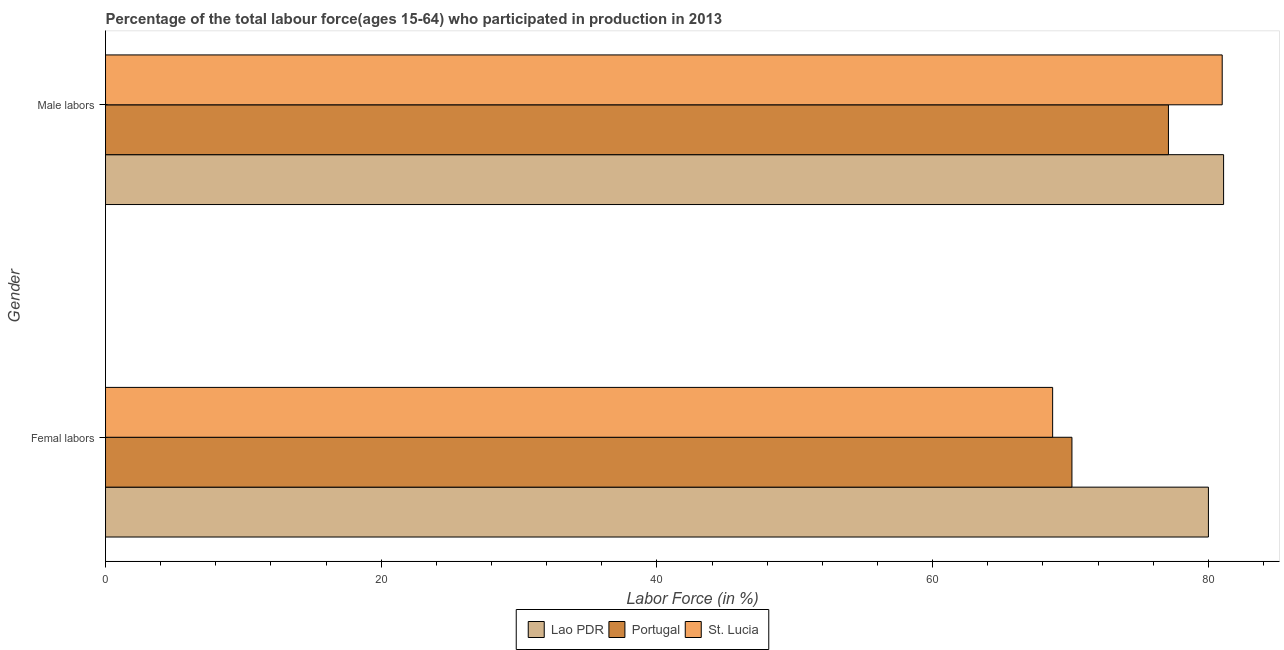How many different coloured bars are there?
Provide a short and direct response. 3. Are the number of bars per tick equal to the number of legend labels?
Your answer should be very brief. Yes. How many bars are there on the 1st tick from the top?
Your answer should be compact. 3. What is the label of the 2nd group of bars from the top?
Provide a short and direct response. Femal labors. What is the percentage of female labor force in Portugal?
Give a very brief answer. 70.1. Across all countries, what is the maximum percentage of female labor force?
Make the answer very short. 80. Across all countries, what is the minimum percentage of female labor force?
Your answer should be compact. 68.7. In which country was the percentage of male labour force maximum?
Keep it short and to the point. Lao PDR. In which country was the percentage of female labor force minimum?
Make the answer very short. St. Lucia. What is the total percentage of female labor force in the graph?
Provide a succinct answer. 218.8. What is the difference between the percentage of female labor force in St. Lucia and that in Portugal?
Your response must be concise. -1.4. What is the difference between the percentage of female labor force in Lao PDR and the percentage of male labour force in St. Lucia?
Provide a short and direct response. -1. What is the average percentage of male labour force per country?
Provide a succinct answer. 79.73. What is the difference between the percentage of male labour force and percentage of female labor force in Portugal?
Make the answer very short. 7. In how many countries, is the percentage of male labour force greater than 8 %?
Make the answer very short. 3. What is the ratio of the percentage of male labour force in Portugal to that in Lao PDR?
Keep it short and to the point. 0.95. Is the percentage of female labor force in Lao PDR less than that in St. Lucia?
Give a very brief answer. No. In how many countries, is the percentage of male labour force greater than the average percentage of male labour force taken over all countries?
Give a very brief answer. 2. What does the 1st bar from the top in Femal labors represents?
Provide a succinct answer. St. Lucia. What does the 1st bar from the bottom in Femal labors represents?
Offer a very short reply. Lao PDR. How many bars are there?
Provide a short and direct response. 6. How many countries are there in the graph?
Your answer should be compact. 3. What is the difference between two consecutive major ticks on the X-axis?
Your answer should be compact. 20. Does the graph contain any zero values?
Provide a succinct answer. No. Does the graph contain grids?
Offer a very short reply. No. How are the legend labels stacked?
Provide a short and direct response. Horizontal. What is the title of the graph?
Give a very brief answer. Percentage of the total labour force(ages 15-64) who participated in production in 2013. What is the label or title of the Y-axis?
Provide a short and direct response. Gender. What is the Labor Force (in %) in Portugal in Femal labors?
Offer a very short reply. 70.1. What is the Labor Force (in %) in St. Lucia in Femal labors?
Provide a short and direct response. 68.7. What is the Labor Force (in %) of Lao PDR in Male labors?
Your answer should be very brief. 81.1. What is the Labor Force (in %) of Portugal in Male labors?
Offer a very short reply. 77.1. What is the Labor Force (in %) in St. Lucia in Male labors?
Keep it short and to the point. 81. Across all Gender, what is the maximum Labor Force (in %) in Lao PDR?
Offer a terse response. 81.1. Across all Gender, what is the maximum Labor Force (in %) in Portugal?
Provide a succinct answer. 77.1. Across all Gender, what is the maximum Labor Force (in %) in St. Lucia?
Give a very brief answer. 81. Across all Gender, what is the minimum Labor Force (in %) of Lao PDR?
Provide a succinct answer. 80. Across all Gender, what is the minimum Labor Force (in %) in Portugal?
Ensure brevity in your answer.  70.1. Across all Gender, what is the minimum Labor Force (in %) in St. Lucia?
Make the answer very short. 68.7. What is the total Labor Force (in %) in Lao PDR in the graph?
Ensure brevity in your answer.  161.1. What is the total Labor Force (in %) in Portugal in the graph?
Your response must be concise. 147.2. What is the total Labor Force (in %) in St. Lucia in the graph?
Provide a succinct answer. 149.7. What is the difference between the Labor Force (in %) in Portugal in Femal labors and that in Male labors?
Your answer should be compact. -7. What is the difference between the Labor Force (in %) of Lao PDR in Femal labors and the Labor Force (in %) of Portugal in Male labors?
Provide a succinct answer. 2.9. What is the average Labor Force (in %) of Lao PDR per Gender?
Offer a very short reply. 80.55. What is the average Labor Force (in %) of Portugal per Gender?
Your answer should be compact. 73.6. What is the average Labor Force (in %) in St. Lucia per Gender?
Keep it short and to the point. 74.85. What is the difference between the Labor Force (in %) of Lao PDR and Labor Force (in %) of St. Lucia in Femal labors?
Ensure brevity in your answer.  11.3. What is the difference between the Labor Force (in %) in Portugal and Labor Force (in %) in St. Lucia in Femal labors?
Your answer should be compact. 1.4. What is the difference between the Labor Force (in %) of Lao PDR and Labor Force (in %) of Portugal in Male labors?
Offer a terse response. 4. What is the ratio of the Labor Force (in %) of Lao PDR in Femal labors to that in Male labors?
Your answer should be compact. 0.99. What is the ratio of the Labor Force (in %) in Portugal in Femal labors to that in Male labors?
Make the answer very short. 0.91. What is the ratio of the Labor Force (in %) of St. Lucia in Femal labors to that in Male labors?
Offer a terse response. 0.85. What is the difference between the highest and the second highest Labor Force (in %) of St. Lucia?
Give a very brief answer. 12.3. What is the difference between the highest and the lowest Labor Force (in %) of Portugal?
Ensure brevity in your answer.  7. 